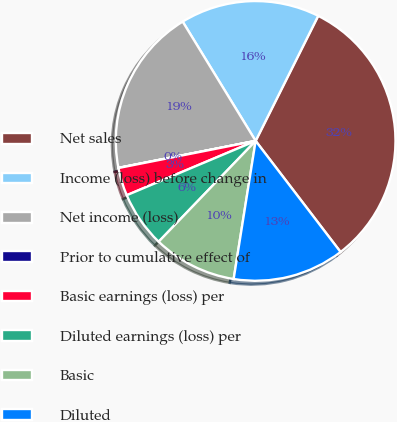Convert chart to OTSL. <chart><loc_0><loc_0><loc_500><loc_500><pie_chart><fcel>Net sales<fcel>Income (loss) before change in<fcel>Net income (loss)<fcel>Prior to cumulative effect of<fcel>Basic earnings (loss) per<fcel>Diluted earnings (loss) per<fcel>Basic<fcel>Diluted<nl><fcel>32.23%<fcel>16.12%<fcel>19.35%<fcel>0.02%<fcel>3.24%<fcel>6.46%<fcel>9.68%<fcel>12.9%<nl></chart> 